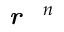Convert formula to latex. <formula><loc_0><loc_0><loc_500><loc_500>r ^ { n }</formula> 